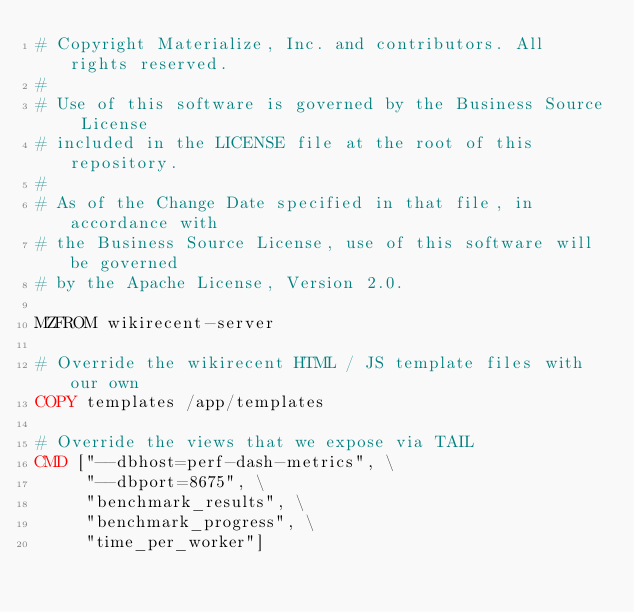Convert code to text. <code><loc_0><loc_0><loc_500><loc_500><_Dockerfile_># Copyright Materialize, Inc. and contributors. All rights reserved.
#
# Use of this software is governed by the Business Source License
# included in the LICENSE file at the root of this repository.
#
# As of the Change Date specified in that file, in accordance with
# the Business Source License, use of this software will be governed
# by the Apache License, Version 2.0.

MZFROM wikirecent-server

# Override the wikirecent HTML / JS template files with our own
COPY templates /app/templates

# Override the views that we expose via TAIL
CMD ["--dbhost=perf-dash-metrics", \
     "--dbport=8675", \
     "benchmark_results", \
     "benchmark_progress", \
     "time_per_worker"]
</code> 